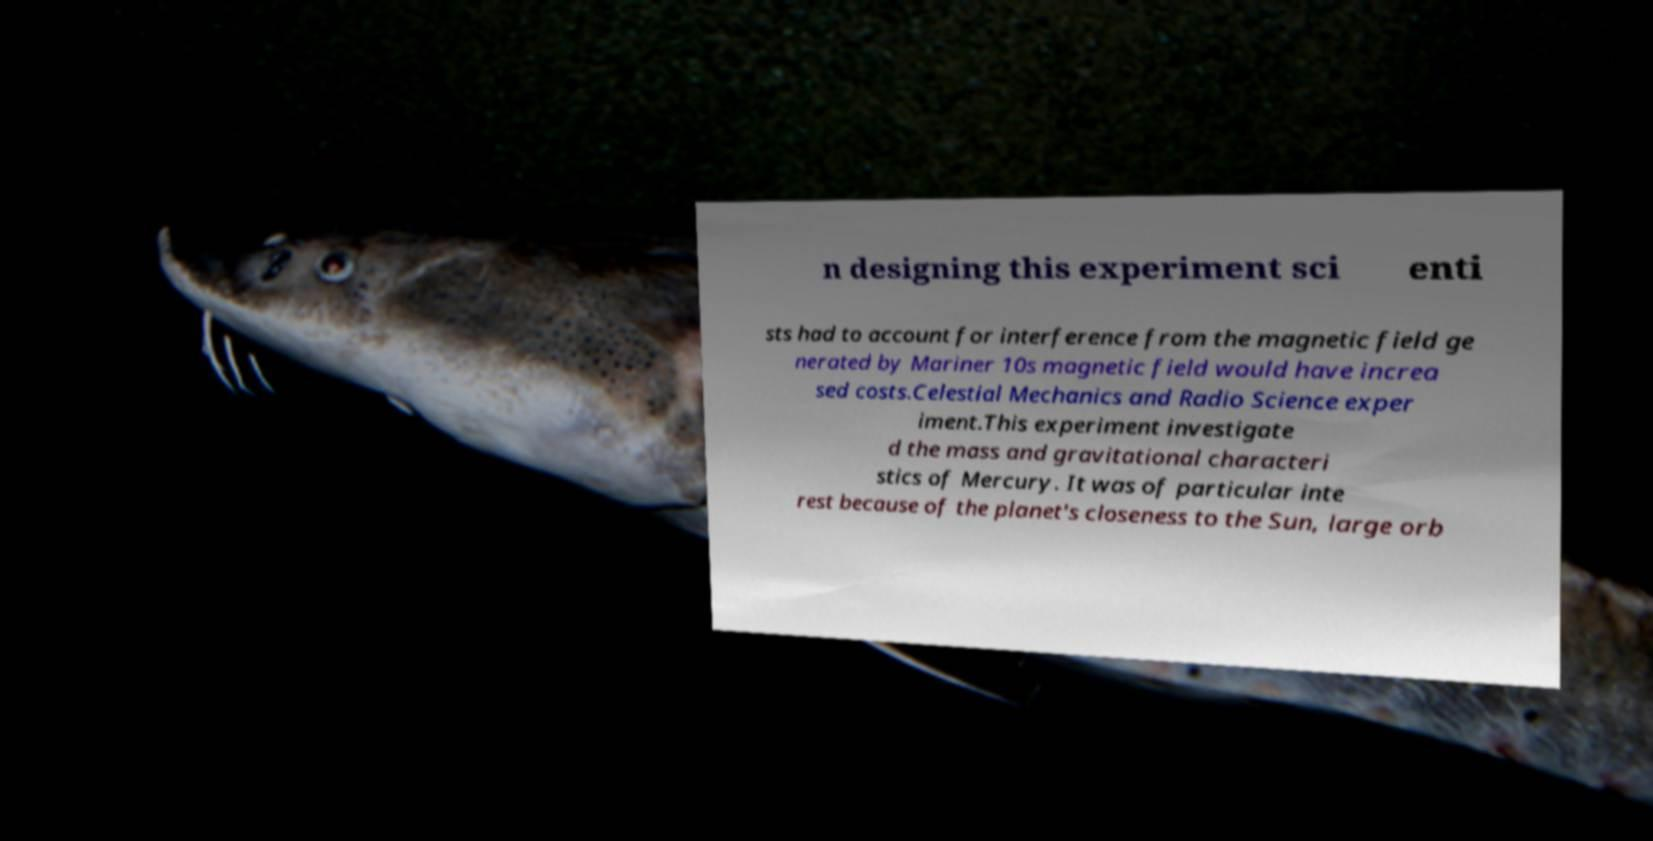There's text embedded in this image that I need extracted. Can you transcribe it verbatim? n designing this experiment sci enti sts had to account for interference from the magnetic field ge nerated by Mariner 10s magnetic field would have increa sed costs.Celestial Mechanics and Radio Science exper iment.This experiment investigate d the mass and gravitational characteri stics of Mercury. It was of particular inte rest because of the planet's closeness to the Sun, large orb 